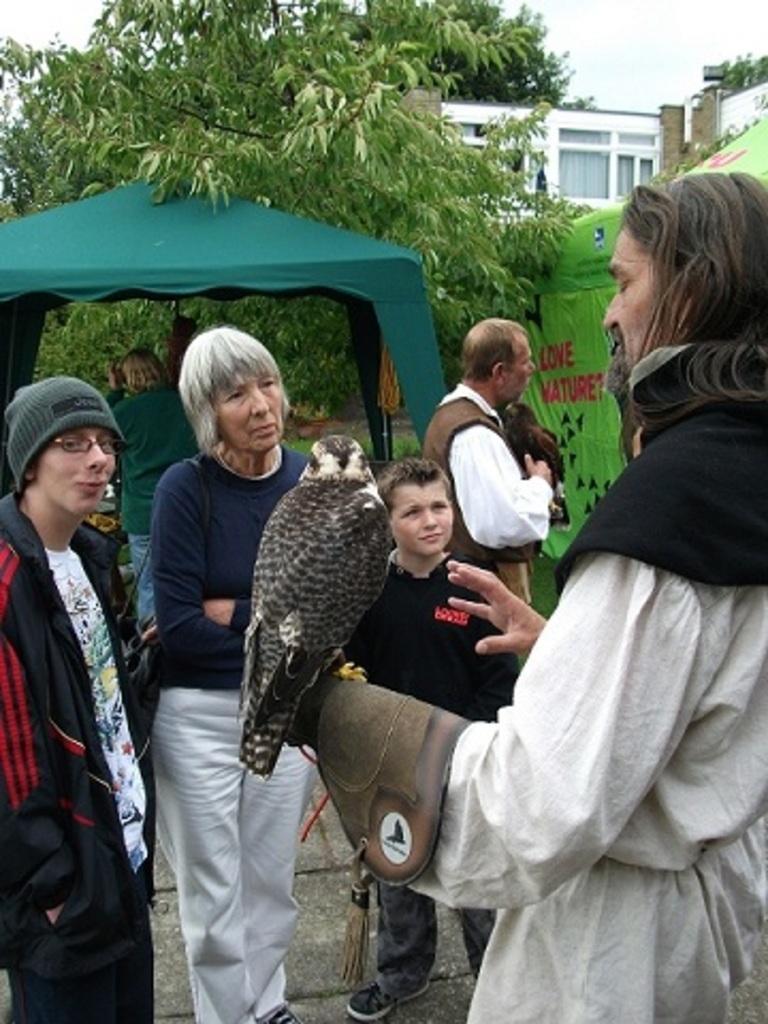How would you summarize this image in a sentence or two? There are four people standing. This is the bird, which is standing on a person´s hand. These look like tents. Here is another man standing and holding a bird. These are the trees. This looks like a building with windows. 